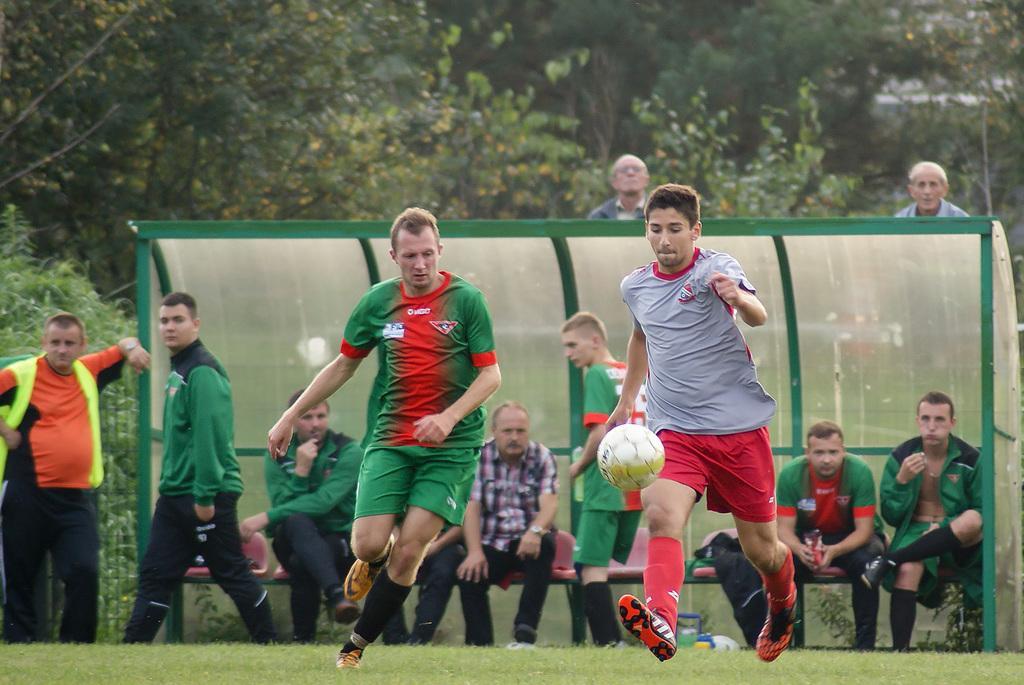In one or two sentences, can you explain what this image depicts? In this image we can see people playing a game. In the center there is a ball. In the background there are people sitting and some of them are standing. There are trees and a stand. At the bottom there is grass. 